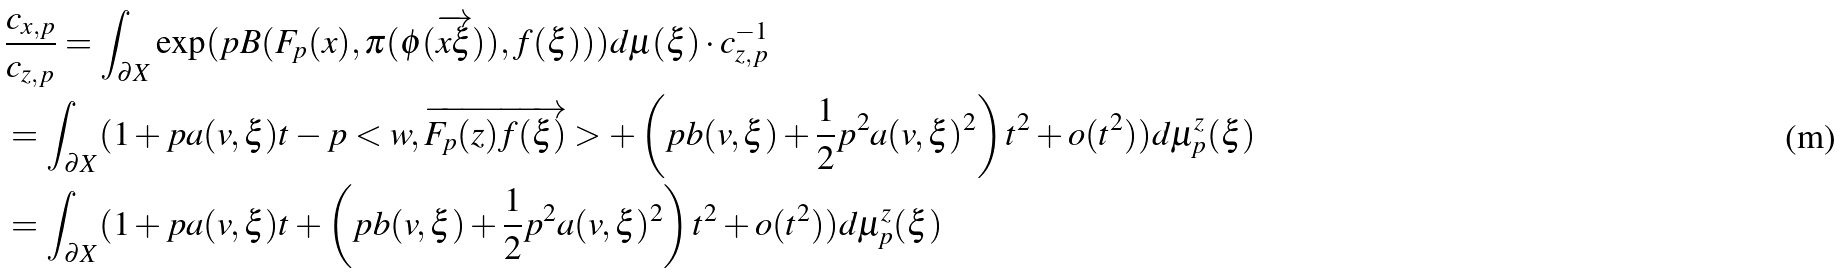Convert formula to latex. <formula><loc_0><loc_0><loc_500><loc_500>& \frac { c _ { x , p } } { c _ { z , p } } = \int _ { \partial X } \exp ( p B ( F _ { p } ( x ) , \pi ( \phi ( \overrightarrow { x \xi } ) ) , f ( \xi ) ) ) d \mu ( \xi ) \cdot c ^ { - 1 } _ { z , p } \\ & = \int _ { \partial X } ( 1 + p a ( v , \xi ) t - p < w , \overrightarrow { F _ { p } ( z ) f ( \xi ) } > + \left ( p b ( v , \xi ) + \frac { 1 } { 2 } p ^ { 2 } a ( v , \xi ) ^ { 2 } \right ) t ^ { 2 } + o ( t ^ { 2 } ) ) d \mu ^ { z } _ { p } ( \xi ) \\ & = \int _ { \partial X } ( 1 + p a ( v , \xi ) t + \left ( p b ( v , \xi ) + \frac { 1 } { 2 } p ^ { 2 } a ( v , \xi ) ^ { 2 } \right ) t ^ { 2 } + o ( t ^ { 2 } ) ) d \mu ^ { z } _ { p } ( \xi ) \\</formula> 